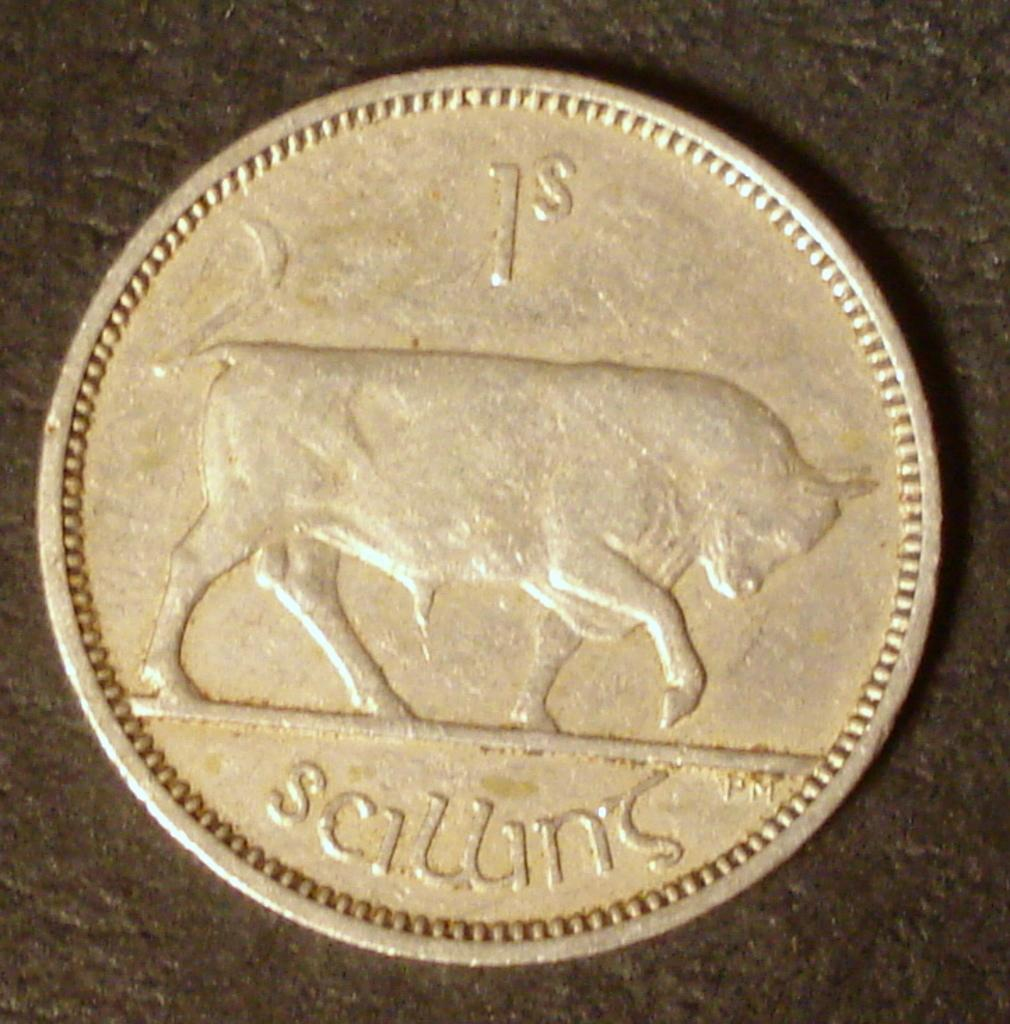<image>
Describe the image concisely. A 1S coin with a bull on it is on a dark background. 